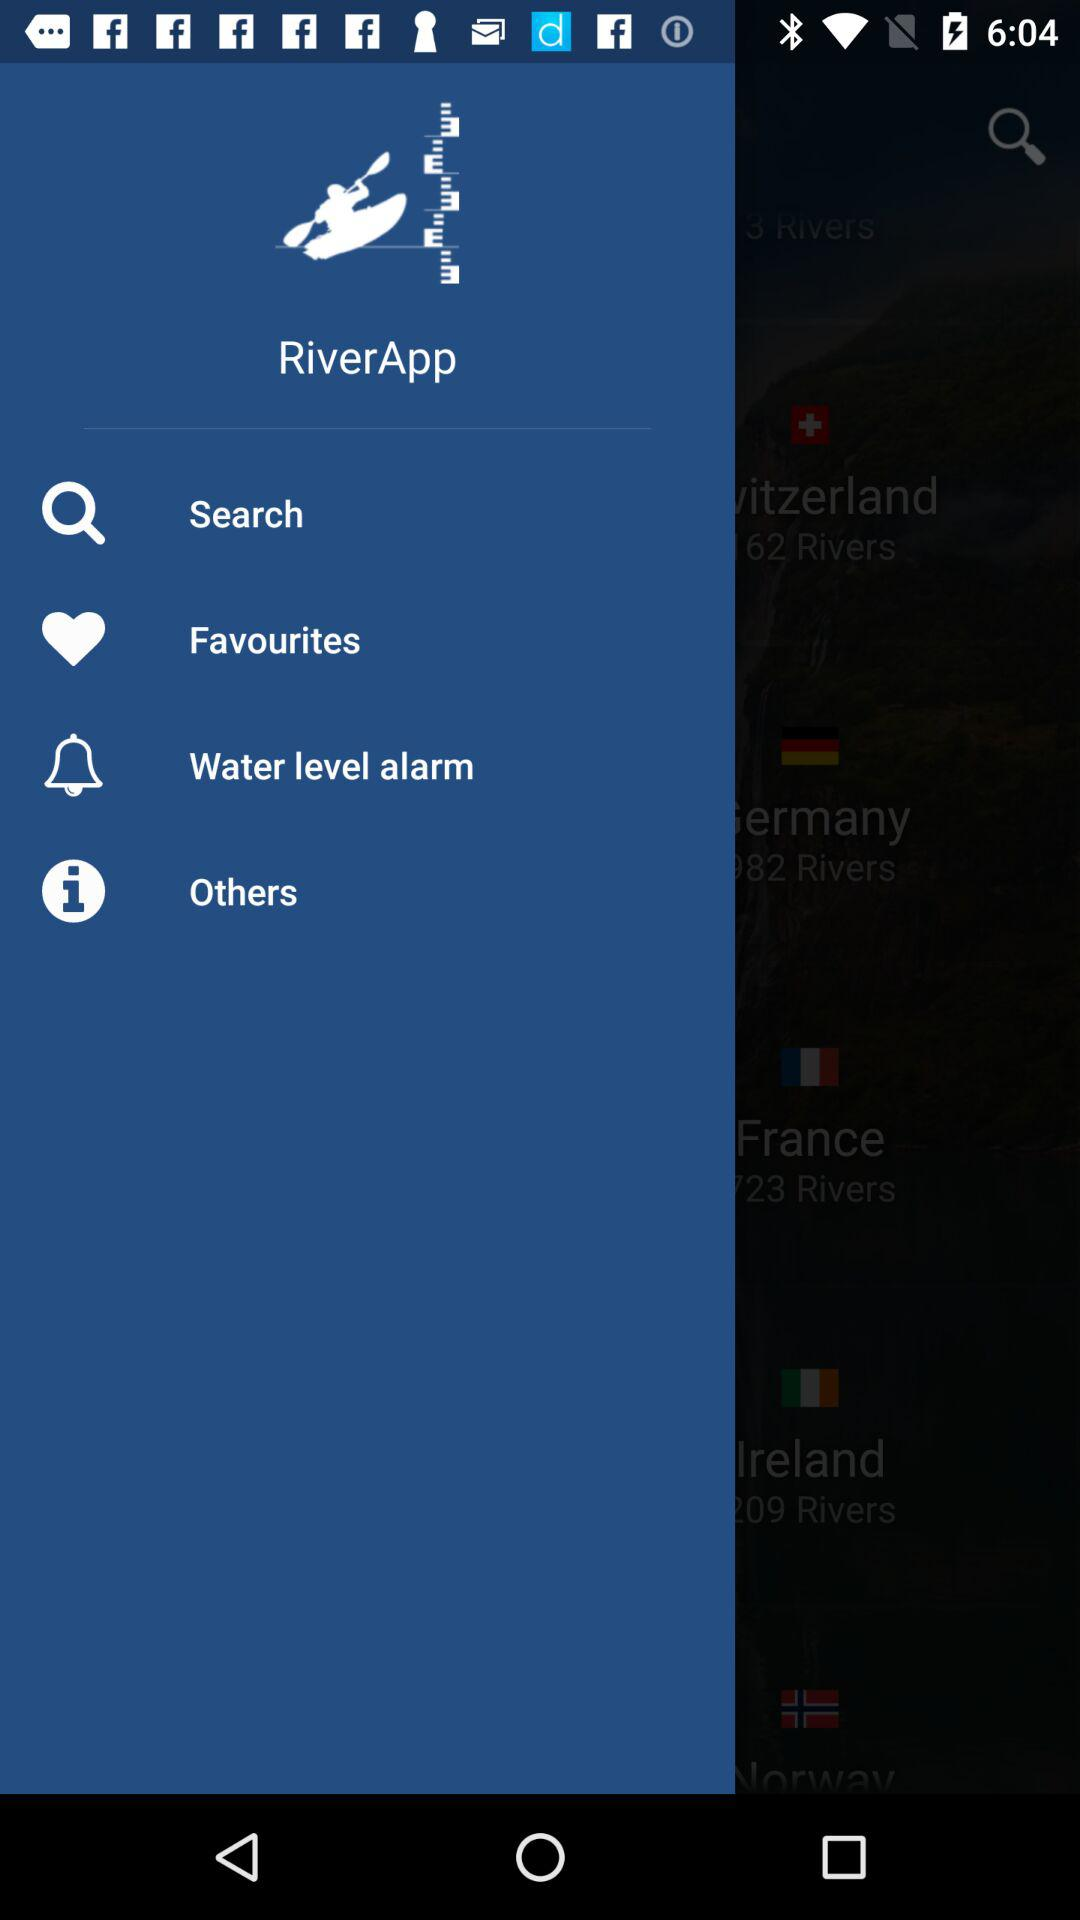What is the name of the application? The name of the application is "RiverApp". 